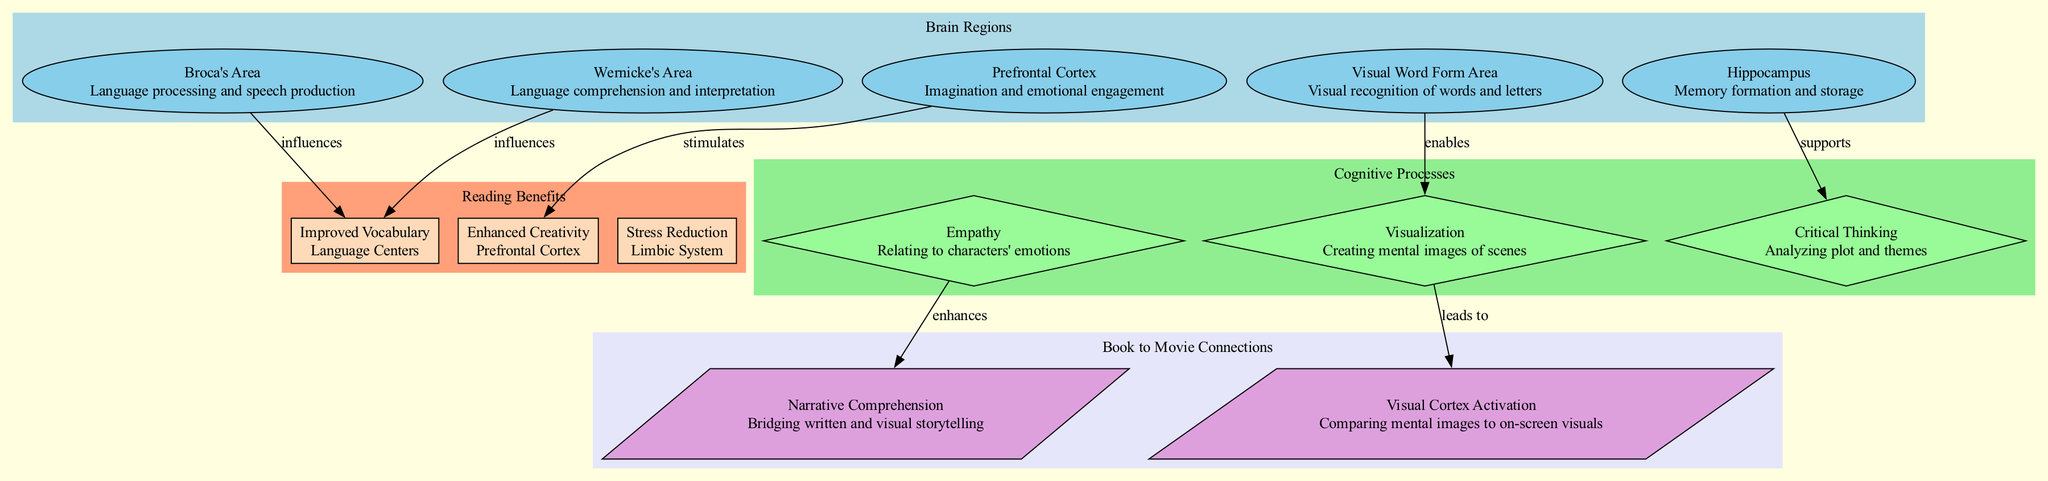What is the function of Broca's Area? Broca's Area is listed with the function of "Language processing and speech production" in the Brain Regions section of the diagram.
Answer: Language processing and speech production How many cognitive processes are displayed in the diagram? The diagram lists three cognitive processes: Empathy, Visualization, and Critical Thinking, which can be counted in the Cognitive Processes section.
Answer: 3 Which brain region supports Critical Thinking? The diagram indicates that the hippocampus supports Critical Thinking, as shown by the connection from the hippocampus to Critical Thinking in the edges between nodes.
Answer: Hippocampus What benefit is associated with the Prefrontal Cortex? The Prefrontal Cortex is linked to "Enhanced Creativity" in the Reading Benefits section of the diagram. The edge indicates a stimulating connection reflecting this benefit.
Answer: Enhanced Creativity What is the relationship between Empathy and Narrative Comprehension? The diagram shows an edge from Empathy to Narrative Comprehension, labeled as "enhances," indicating that Empathy contributes positively to Narrative Comprehension.
Answer: enhances Which area is improved by reading, according to the diagram? The diagram lists "Improved Vocabulary" under Reading Benefits, connected to Broca's Area and Wernicke's Area which influence this improvement in the Language Centers.
Answer: Improved Vocabulary What activates the Visual Cortex during reading? The diagram indicates that Visualization leads to "Visual Cortex Activation," which shows a direct relationship between these two cognitive processes in the reading context.
Answer: Visual Cortex Activation How does the Hippocampus influence Critical Thinking? The Hippocampus is directly connected to Critical Thinking with the label "supports," meaning it has a supportive influence over that cognitive process during reading.
Answer: supports What connects Visualization and Visual Cortex Activation? The edge labeled "leads to" indicates that Visualization initiates or results in Visual Cortex Activation as part of the reading process.
Answer: leads to 